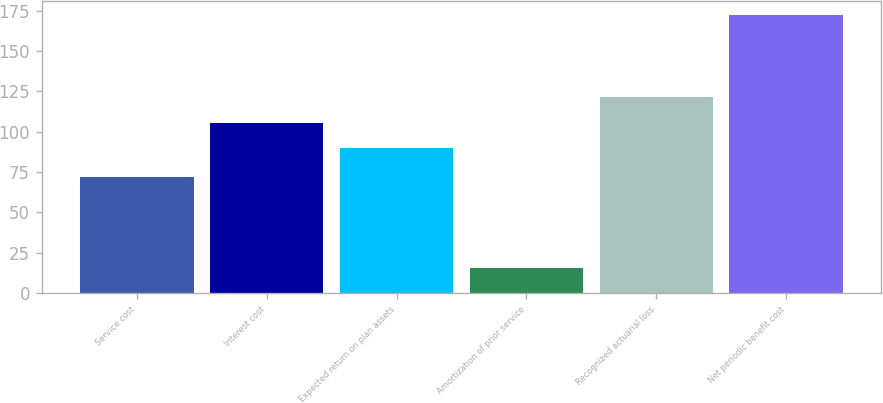Convert chart. <chart><loc_0><loc_0><loc_500><loc_500><bar_chart><fcel>Service cost<fcel>Interest cost<fcel>Expected return on plan assets<fcel>Amortization of prior service<fcel>Recognized actuarial loss<fcel>Net periodic benefit cost<nl><fcel>72.2<fcel>105.59<fcel>89.9<fcel>15.6<fcel>121.28<fcel>172.5<nl></chart> 